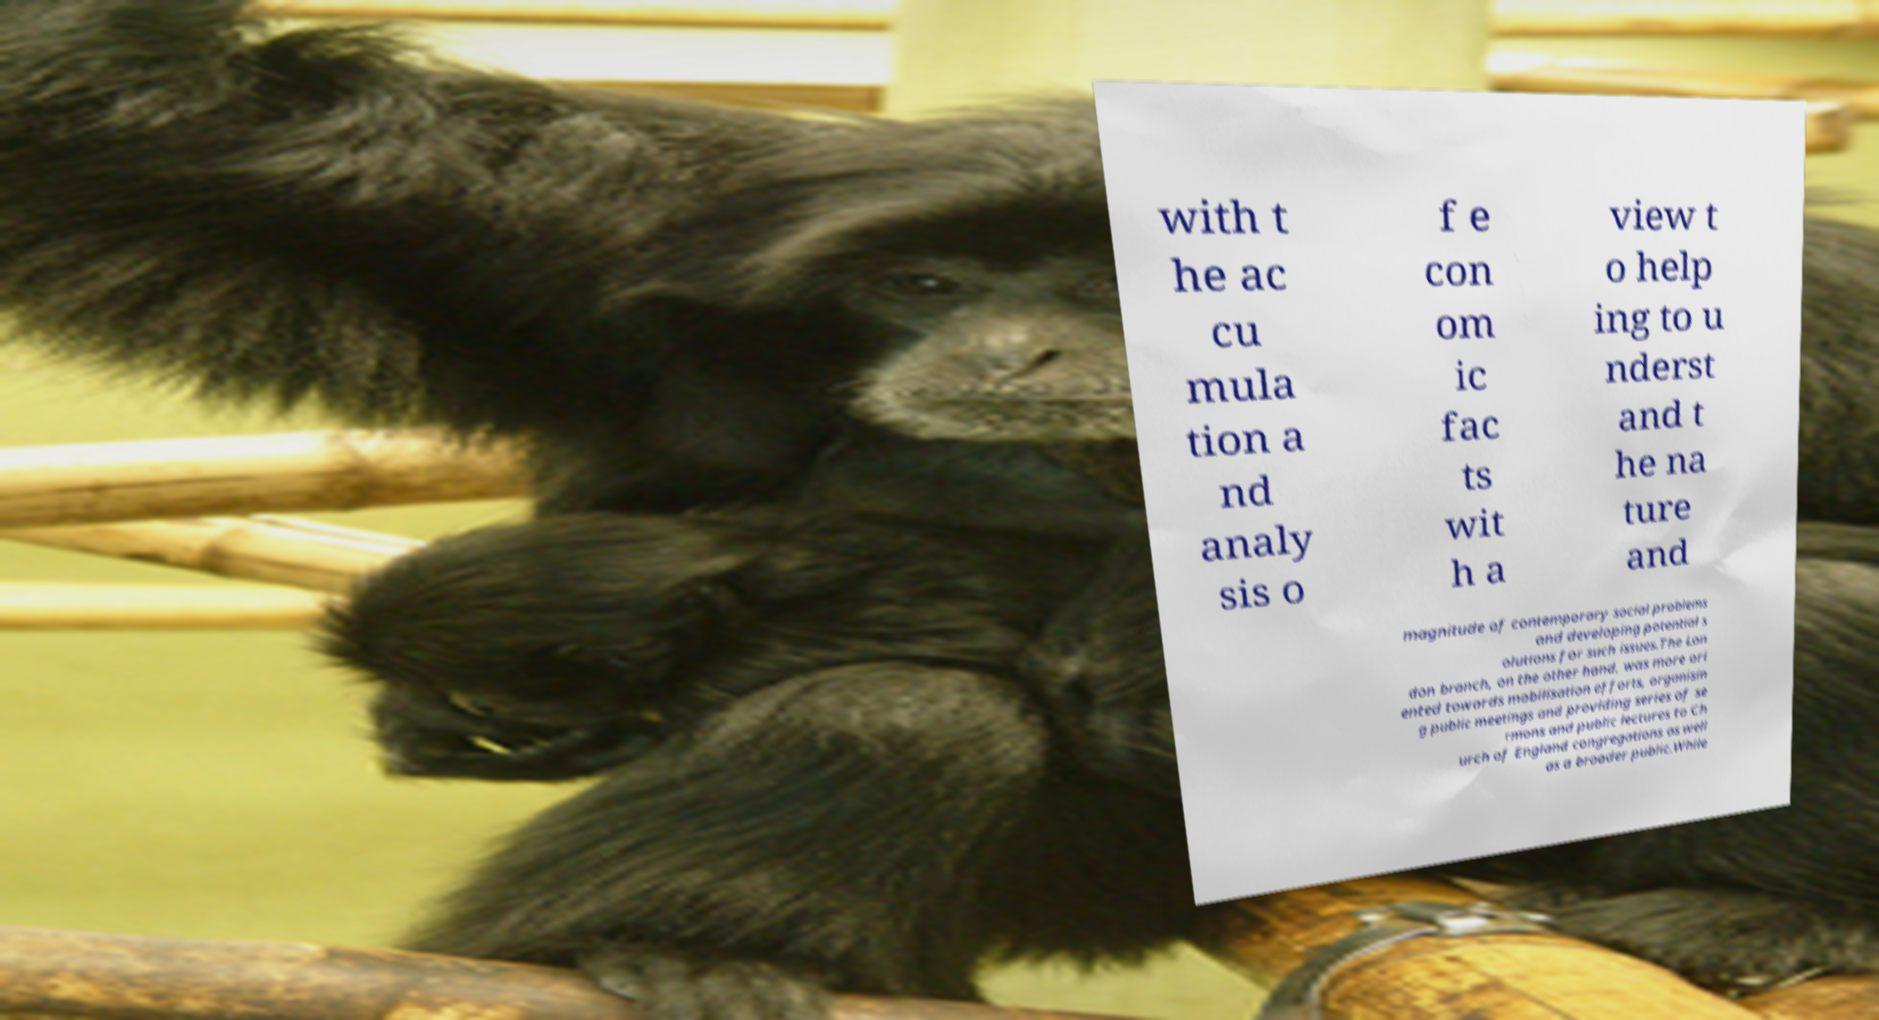Could you extract and type out the text from this image? with t he ac cu mula tion a nd analy sis o f e con om ic fac ts wit h a view t o help ing to u nderst and t he na ture and magnitude of contemporary social problems and developing potential s olutions for such issues.The Lon don branch, on the other hand, was more ori ented towards mobilisation efforts, organisin g public meetings and providing series of se rmons and public lectures to Ch urch of England congregations as well as a broader public.While 